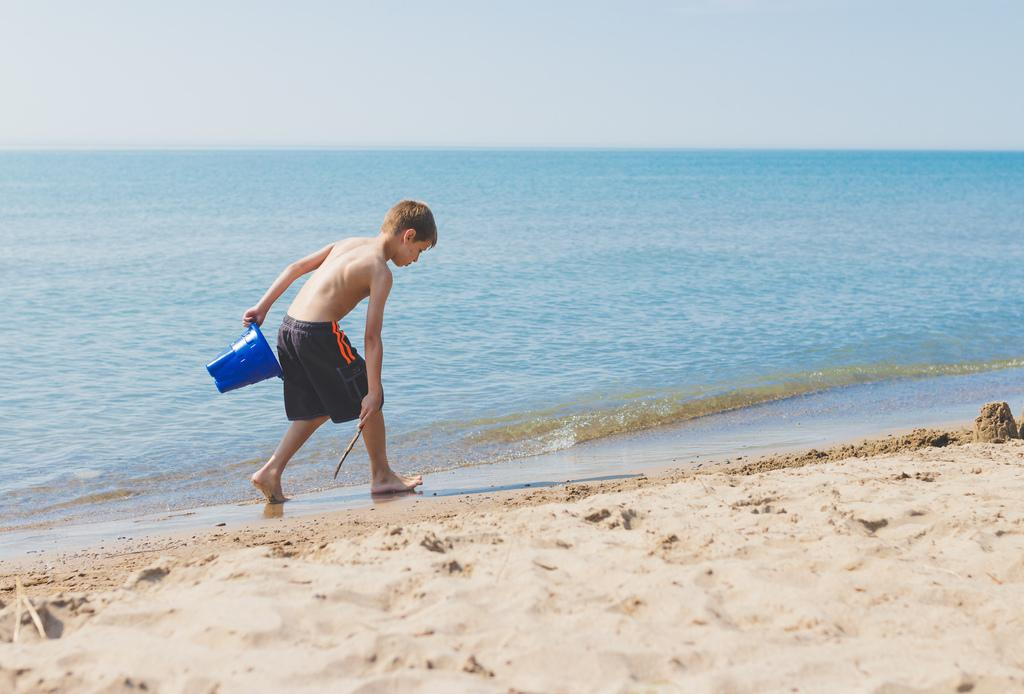Who is present in the image? There is a person in the image. What is the person doing in the image? The person is carrying objects and walking on the sea shore. What type of terrain can be seen in the image? There is sand visible in the image. What verse is the snail reciting while walking on the sand in the image? There is no snail present in the image, and therefore no verse can be heard or observed. 